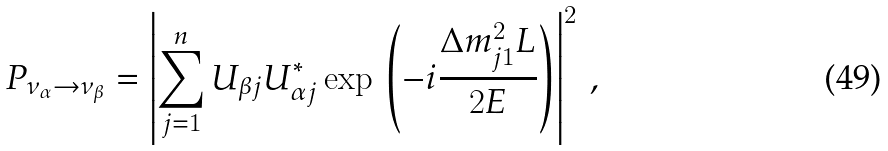<formula> <loc_0><loc_0><loc_500><loc_500>P _ { \nu _ { \alpha } \rightarrow \nu _ { \beta } } = \left | \sum _ { j = 1 } ^ { n } U _ { \beta j } U _ { \alpha j } ^ { * } \exp \, \left ( - i \frac { \Delta { m } ^ { 2 } _ { j 1 } L } { 2 E } \right ) \right | ^ { 2 } \, ,</formula> 